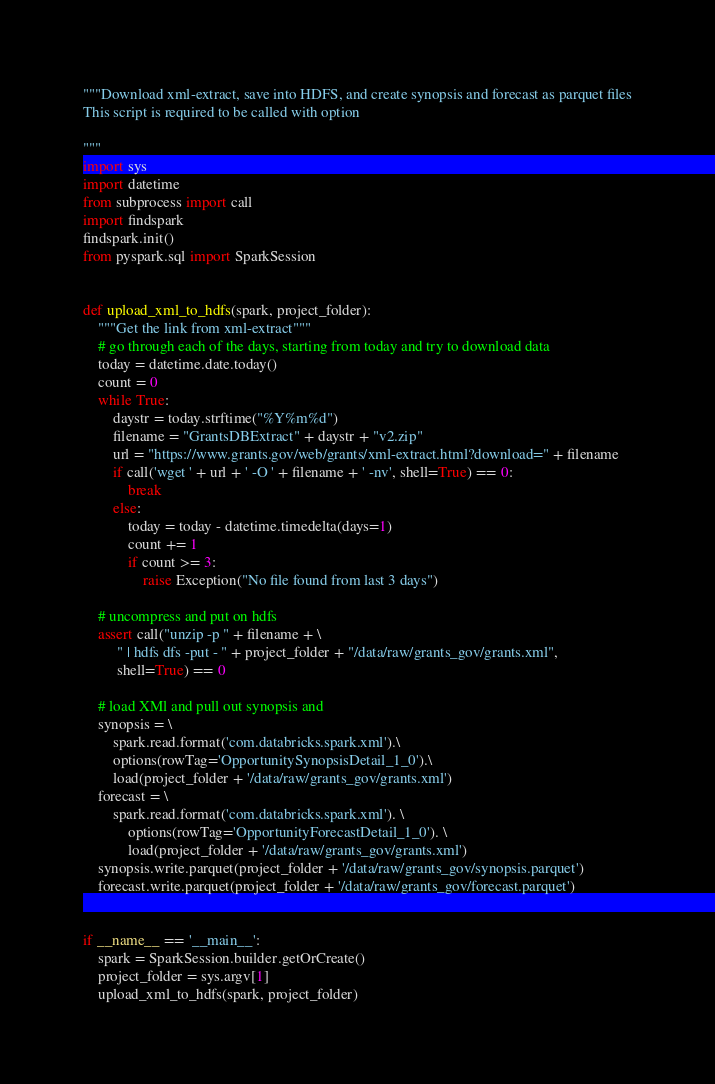<code> <loc_0><loc_0><loc_500><loc_500><_Python_>"""Download xml-extract, save into HDFS, and create synopsis and forecast as parquet files
This script is required to be called with option

"""
import sys
import datetime
from subprocess import call
import findspark
findspark.init()
from pyspark.sql import SparkSession


def upload_xml_to_hdfs(spark, project_folder):
    """Get the link from xml-extract"""
    # go through each of the days, starting from today and try to download data
    today = datetime.date.today()
    count = 0
    while True:
        daystr = today.strftime("%Y%m%d")
        filename = "GrantsDBExtract" + daystr + "v2.zip"
        url = "https://www.grants.gov/web/grants/xml-extract.html?download=" + filename
        if call('wget ' + url + ' -O ' + filename + ' -nv', shell=True) == 0:
            break
        else:
            today = today - datetime.timedelta(days=1)
            count += 1
            if count >= 3:
                raise Exception("No file found from last 3 days")

    # uncompress and put on hdfs
    assert call("unzip -p " + filename + \
         " | hdfs dfs -put - " + project_folder + "/data/raw/grants_gov/grants.xml",
         shell=True) == 0

    # load XMl and pull out synopsis and
    synopsis = \
        spark.read.format('com.databricks.spark.xml').\
        options(rowTag='OpportunitySynopsisDetail_1_0').\
        load(project_folder + '/data/raw/grants_gov/grants.xml')
    forecast = \
        spark.read.format('com.databricks.spark.xml'). \
            options(rowTag='OpportunityForecastDetail_1_0'). \
            load(project_folder + '/data/raw/grants_gov/grants.xml')
    synopsis.write.parquet(project_folder + '/data/raw/grants_gov/synopsis.parquet')
    forecast.write.parquet(project_folder + '/data/raw/grants_gov/forecast.parquet')


if __name__ == '__main__':
    spark = SparkSession.builder.getOrCreate()
    project_folder = sys.argv[1]
    upload_xml_to_hdfs(spark, project_folder)</code> 